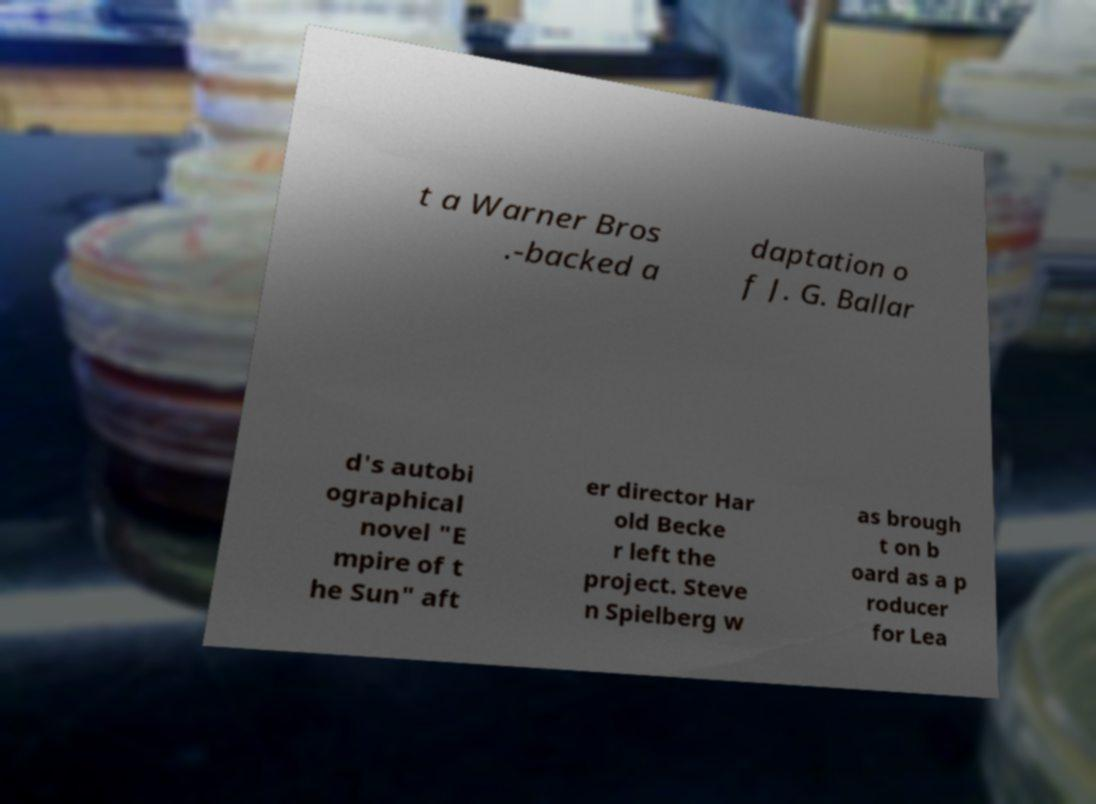What messages or text are displayed in this image? I need them in a readable, typed format. t a Warner Bros .-backed a daptation o f J. G. Ballar d's autobi ographical novel "E mpire of t he Sun" aft er director Har old Becke r left the project. Steve n Spielberg w as brough t on b oard as a p roducer for Lea 